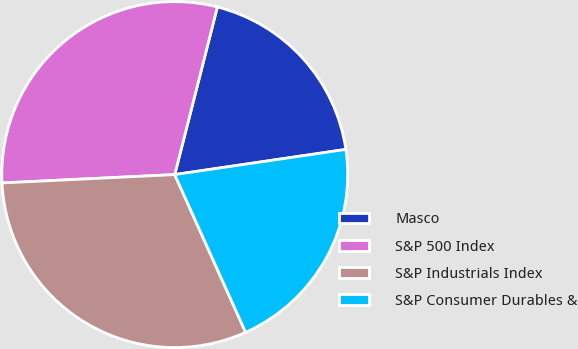<chart> <loc_0><loc_0><loc_500><loc_500><pie_chart><fcel>Masco<fcel>S&P 500 Index<fcel>S&P Industrials Index<fcel>S&P Consumer Durables &<nl><fcel>18.71%<fcel>29.73%<fcel>30.95%<fcel>20.6%<nl></chart> 